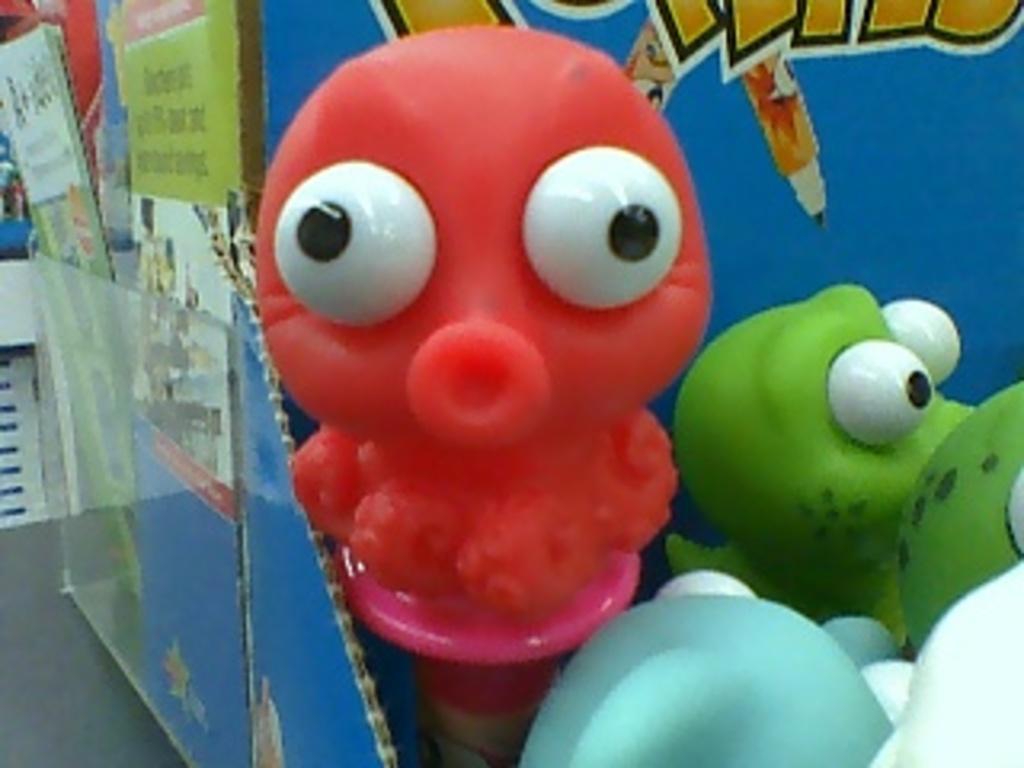In one or two sentences, can you explain what this image depicts? In the center of the image there are toys. In the background there is a board. 